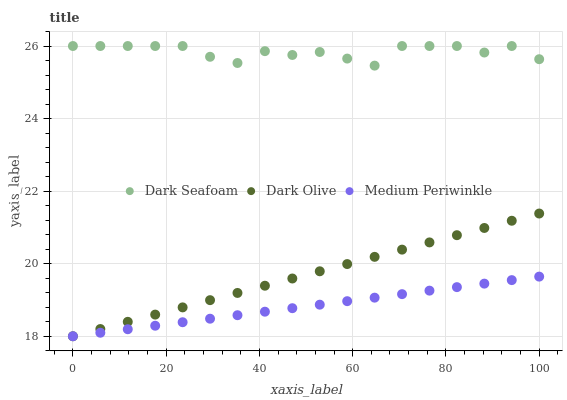Does Medium Periwinkle have the minimum area under the curve?
Answer yes or no. Yes. Does Dark Seafoam have the maximum area under the curve?
Answer yes or no. Yes. Does Dark Olive have the minimum area under the curve?
Answer yes or no. No. Does Dark Olive have the maximum area under the curve?
Answer yes or no. No. Is Medium Periwinkle the smoothest?
Answer yes or no. Yes. Is Dark Seafoam the roughest?
Answer yes or no. Yes. Is Dark Olive the smoothest?
Answer yes or no. No. Is Dark Olive the roughest?
Answer yes or no. No. Does Dark Olive have the lowest value?
Answer yes or no. Yes. Does Dark Seafoam have the highest value?
Answer yes or no. Yes. Does Dark Olive have the highest value?
Answer yes or no. No. Is Dark Olive less than Dark Seafoam?
Answer yes or no. Yes. Is Dark Seafoam greater than Dark Olive?
Answer yes or no. Yes. Does Dark Olive intersect Medium Periwinkle?
Answer yes or no. Yes. Is Dark Olive less than Medium Periwinkle?
Answer yes or no. No. Is Dark Olive greater than Medium Periwinkle?
Answer yes or no. No. Does Dark Olive intersect Dark Seafoam?
Answer yes or no. No. 